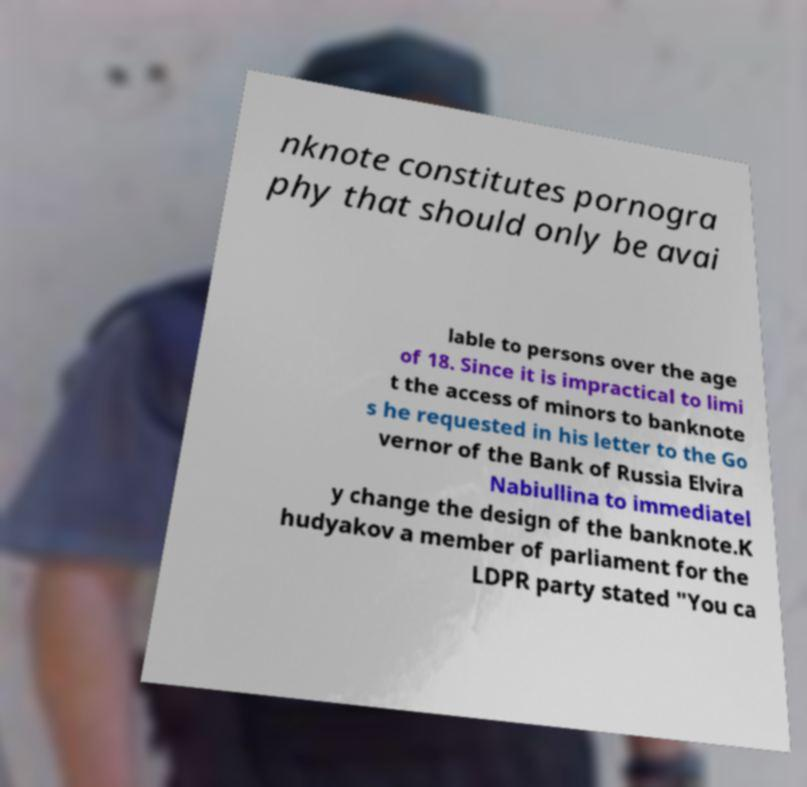I need the written content from this picture converted into text. Can you do that? nknote constitutes pornogra phy that should only be avai lable to persons over the age of 18. Since it is impractical to limi t the access of minors to banknote s he requested in his letter to the Go vernor of the Bank of Russia Elvira Nabiullina to immediatel y change the design of the banknote.K hudyakov a member of parliament for the LDPR party stated "You ca 